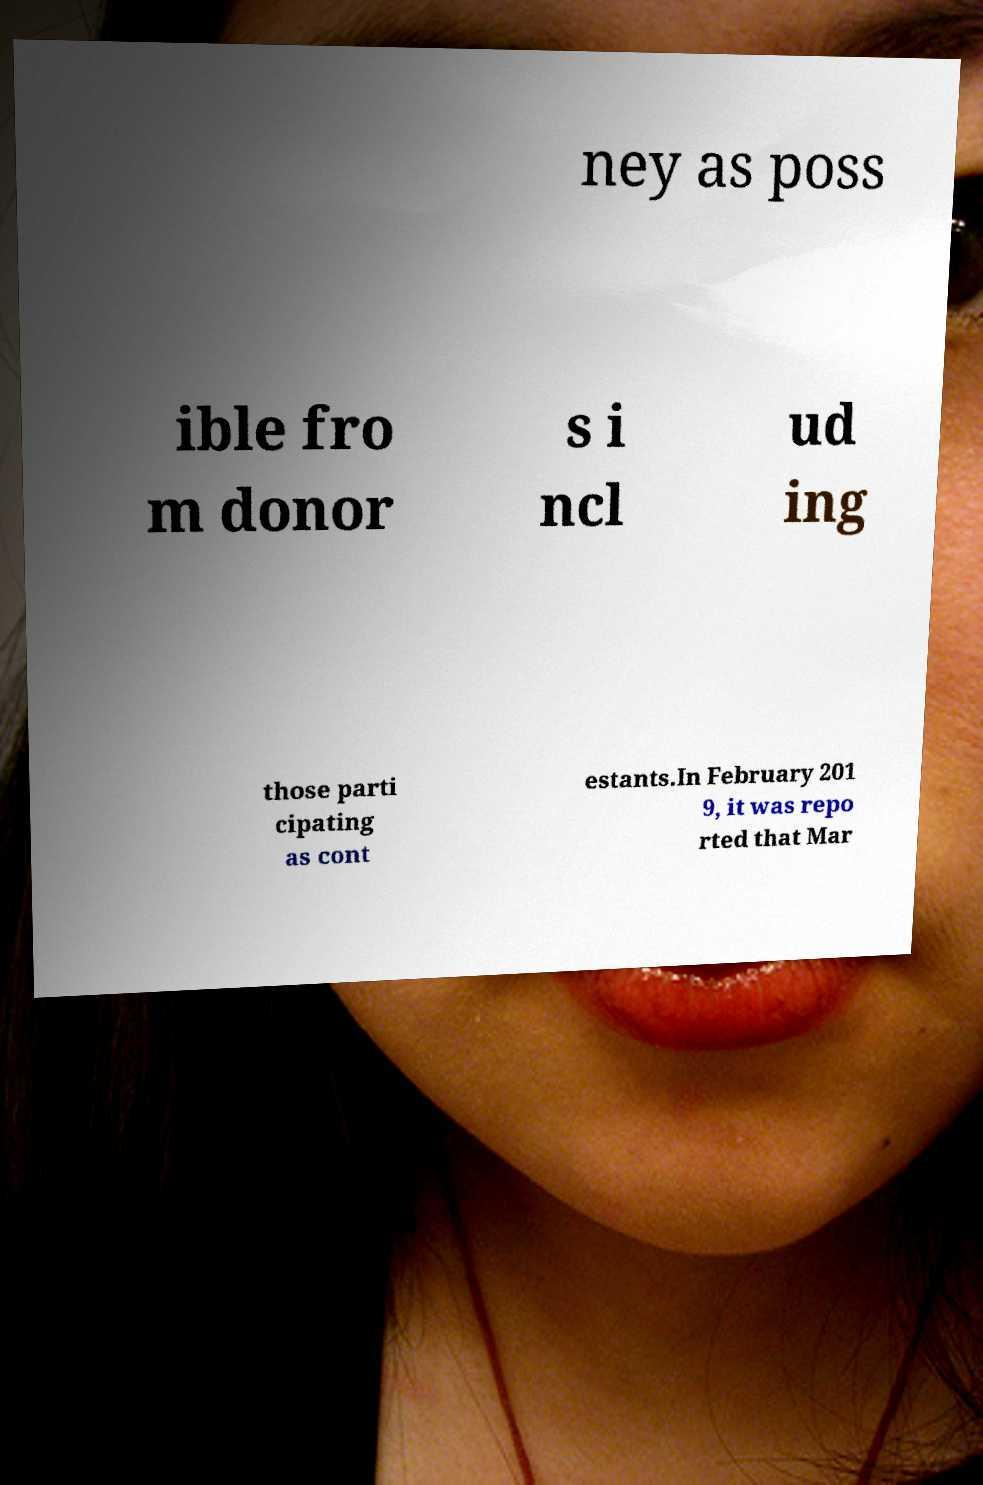I need the written content from this picture converted into text. Can you do that? ney as poss ible fro m donor s i ncl ud ing those parti cipating as cont estants.In February 201 9, it was repo rted that Mar 